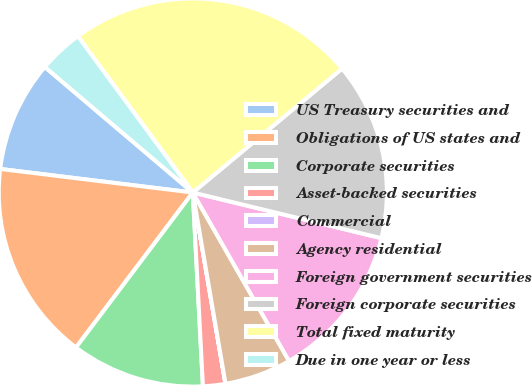Convert chart to OTSL. <chart><loc_0><loc_0><loc_500><loc_500><pie_chart><fcel>US Treasury securities and<fcel>Obligations of US states and<fcel>Corporate securities<fcel>Asset-backed securities<fcel>Commercial<fcel>Agency residential<fcel>Foreign government securities<fcel>Foreign corporate securities<fcel>Total fixed maturity<fcel>Due in one year or less<nl><fcel>9.26%<fcel>16.66%<fcel>11.11%<fcel>1.86%<fcel>0.01%<fcel>5.56%<fcel>12.96%<fcel>14.81%<fcel>24.06%<fcel>3.71%<nl></chart> 